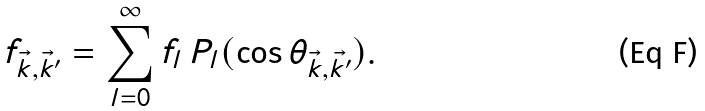Convert formula to latex. <formula><loc_0><loc_0><loc_500><loc_500>f _ { \vec { k } , \vec { k } ^ { \prime } } = \sum _ { l = 0 } ^ { \infty } f _ { l } \, P _ { l } ( \cos \theta _ { \vec { k } , \vec { k ^ { \prime } } } ) .</formula> 